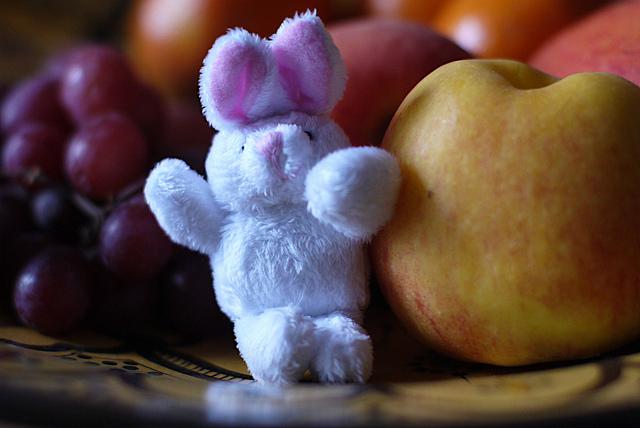What purple fruit is shown?
Answer briefly. Grapes. Is the bunny bigger than the apple beside it?
Give a very brief answer. No. How many different types of products are present?
Quick response, please. 2. 